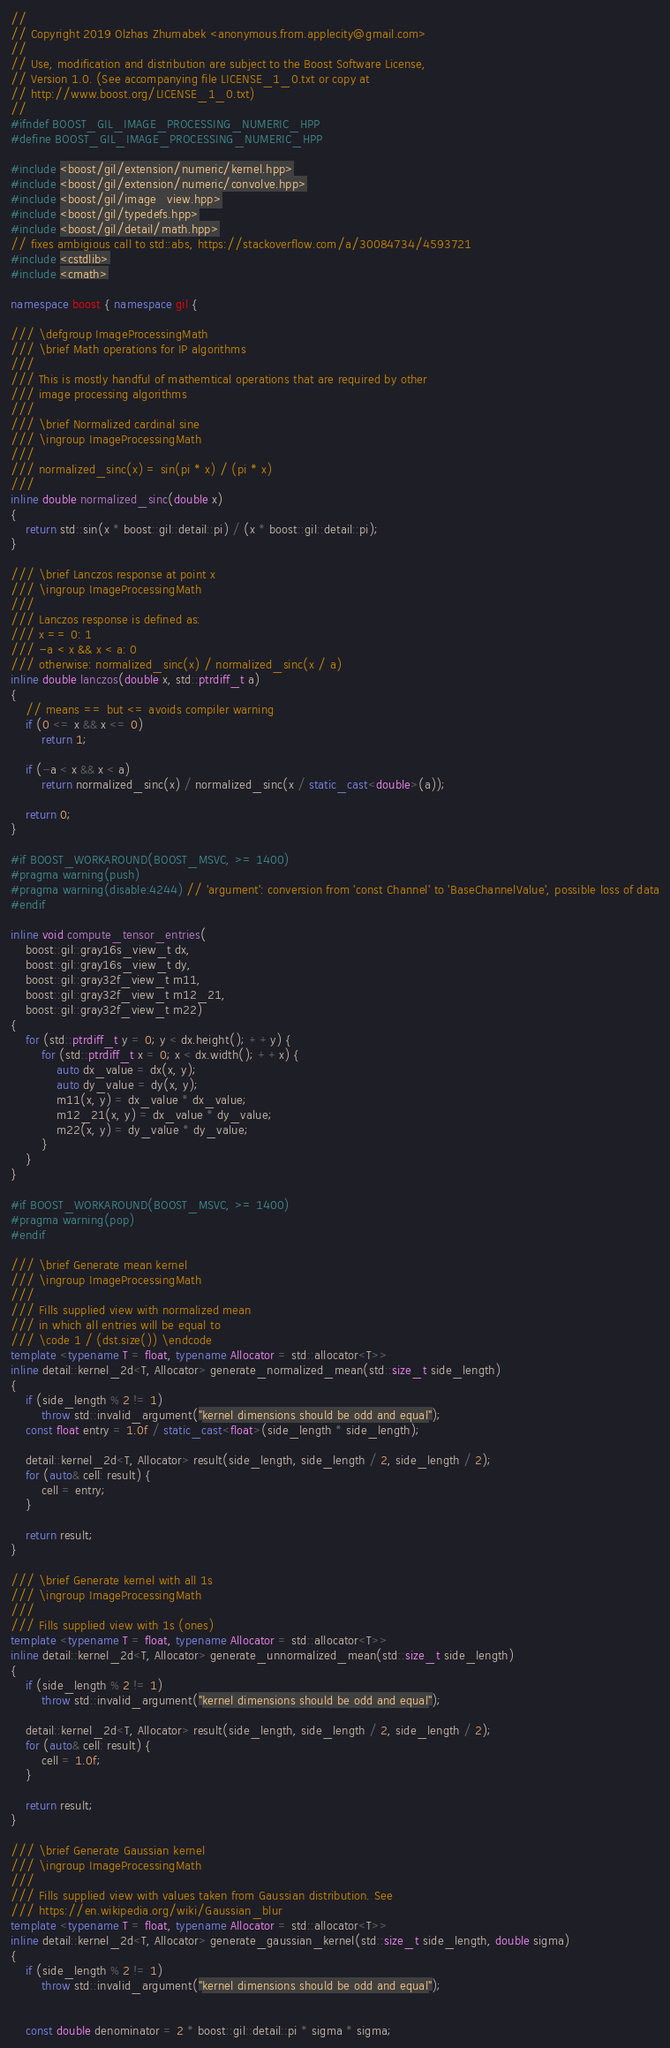Convert code to text. <code><loc_0><loc_0><loc_500><loc_500><_C++_>//
// Copyright 2019 Olzhas Zhumabek <anonymous.from.applecity@gmail.com>
//
// Use, modification and distribution are subject to the Boost Software License,
// Version 1.0. (See accompanying file LICENSE_1_0.txt or copy at
// http://www.boost.org/LICENSE_1_0.txt)
//
#ifndef BOOST_GIL_IMAGE_PROCESSING_NUMERIC_HPP
#define BOOST_GIL_IMAGE_PROCESSING_NUMERIC_HPP

#include <boost/gil/extension/numeric/kernel.hpp>
#include <boost/gil/extension/numeric/convolve.hpp>
#include <boost/gil/image_view.hpp>
#include <boost/gil/typedefs.hpp>
#include <boost/gil/detail/math.hpp>
// fixes ambigious call to std::abs, https://stackoverflow.com/a/30084734/4593721
#include <cstdlib>
#include <cmath>

namespace boost { namespace gil {

/// \defgroup ImageProcessingMath
/// \brief Math operations for IP algorithms
///
/// This is mostly handful of mathemtical operations that are required by other
/// image processing algorithms
///
/// \brief Normalized cardinal sine
/// \ingroup ImageProcessingMath
///
/// normalized_sinc(x) = sin(pi * x) / (pi * x)
///
inline double normalized_sinc(double x)
{
    return std::sin(x * boost::gil::detail::pi) / (x * boost::gil::detail::pi);
}

/// \brief Lanczos response at point x
/// \ingroup ImageProcessingMath
///
/// Lanczos response is defined as:
/// x == 0: 1
/// -a < x && x < a: 0
/// otherwise: normalized_sinc(x) / normalized_sinc(x / a)
inline double lanczos(double x, std::ptrdiff_t a)
{
    // means == but <= avoids compiler warning
    if (0 <= x && x <= 0)
        return 1;

    if (-a < x && x < a)
        return normalized_sinc(x) / normalized_sinc(x / static_cast<double>(a));

    return 0;
}

#if BOOST_WORKAROUND(BOOST_MSVC, >= 1400)
#pragma warning(push)
#pragma warning(disable:4244) // 'argument': conversion from 'const Channel' to 'BaseChannelValue', possible loss of data
#endif

inline void compute_tensor_entries(
    boost::gil::gray16s_view_t dx,
    boost::gil::gray16s_view_t dy,
    boost::gil::gray32f_view_t m11,
    boost::gil::gray32f_view_t m12_21,
    boost::gil::gray32f_view_t m22)
{
    for (std::ptrdiff_t y = 0; y < dx.height(); ++y) {
        for (std::ptrdiff_t x = 0; x < dx.width(); ++x) {
            auto dx_value = dx(x, y);
            auto dy_value = dy(x, y);
            m11(x, y) = dx_value * dx_value;
            m12_21(x, y) = dx_value * dy_value;
            m22(x, y) = dy_value * dy_value;
        }
    }
}

#if BOOST_WORKAROUND(BOOST_MSVC, >= 1400)
#pragma warning(pop)
#endif

/// \brief Generate mean kernel
/// \ingroup ImageProcessingMath
///
/// Fills supplied view with normalized mean
/// in which all entries will be equal to
/// \code 1 / (dst.size()) \endcode
template <typename T = float, typename Allocator = std::allocator<T>>
inline detail::kernel_2d<T, Allocator> generate_normalized_mean(std::size_t side_length)
{
    if (side_length % 2 != 1)
        throw std::invalid_argument("kernel dimensions should be odd and equal");
    const float entry = 1.0f / static_cast<float>(side_length * side_length);

    detail::kernel_2d<T, Allocator> result(side_length, side_length / 2, side_length / 2);
    for (auto& cell: result) {
        cell = entry;
    }

    return result;
}

/// \brief Generate kernel with all 1s
/// \ingroup ImageProcessingMath
///
/// Fills supplied view with 1s (ones)
template <typename T = float, typename Allocator = std::allocator<T>>
inline detail::kernel_2d<T, Allocator> generate_unnormalized_mean(std::size_t side_length)
{
    if (side_length % 2 != 1)
        throw std::invalid_argument("kernel dimensions should be odd and equal");

    detail::kernel_2d<T, Allocator> result(side_length, side_length / 2, side_length / 2);
    for (auto& cell: result) {
        cell = 1.0f;
    }

    return result;
}

/// \brief Generate Gaussian kernel
/// \ingroup ImageProcessingMath
///
/// Fills supplied view with values taken from Gaussian distribution. See
/// https://en.wikipedia.org/wiki/Gaussian_blur
template <typename T = float, typename Allocator = std::allocator<T>>
inline detail::kernel_2d<T, Allocator> generate_gaussian_kernel(std::size_t side_length, double sigma)
{
    if (side_length % 2 != 1)
        throw std::invalid_argument("kernel dimensions should be odd and equal");


    const double denominator = 2 * boost::gil::detail::pi * sigma * sigma;</code> 